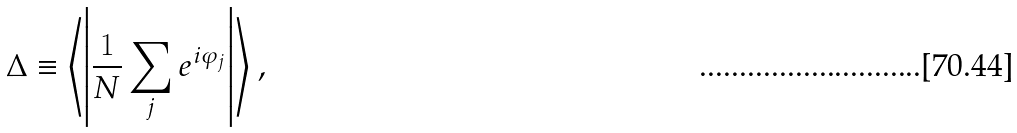<formula> <loc_0><loc_0><loc_500><loc_500>\Delta \equiv \left \langle \left | \frac { 1 } { N } \sum _ { j } e ^ { i \varphi _ { j } } \right | \right \rangle ,</formula> 